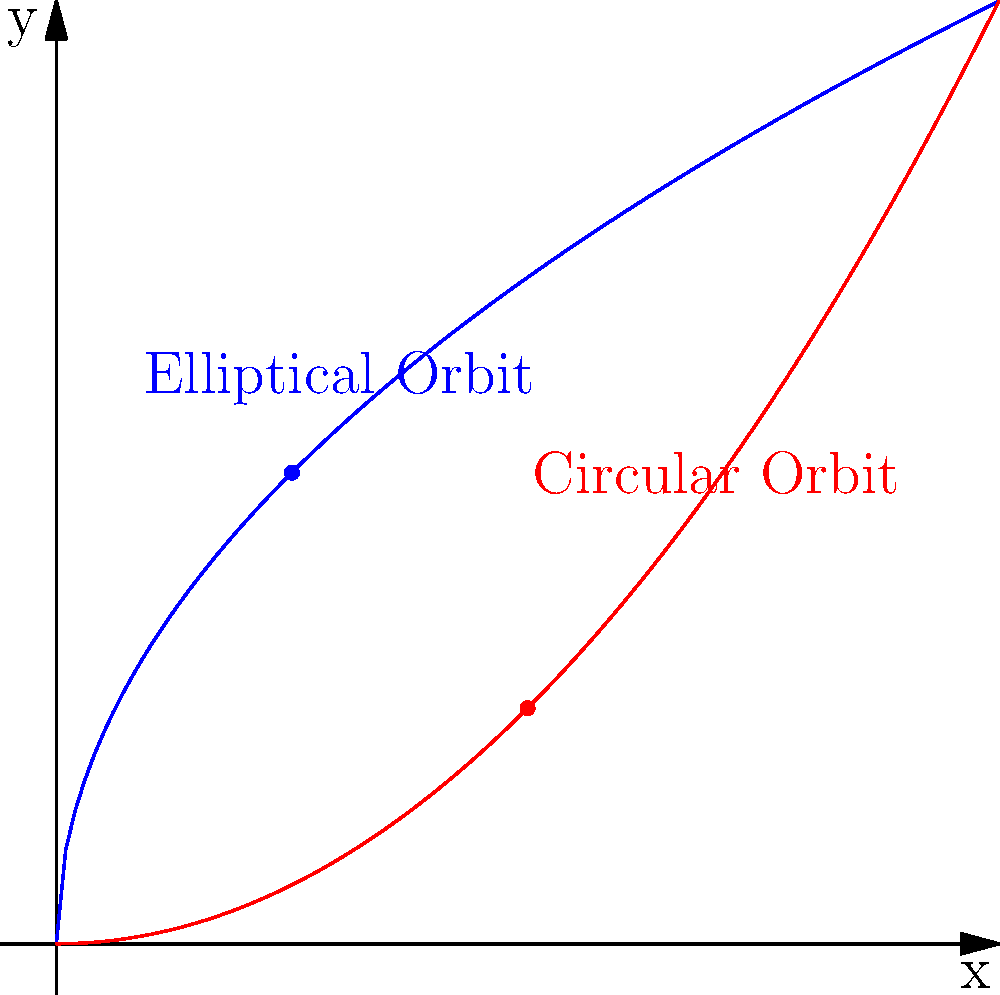Consider the graph above, where the blue curve represents an elliptical orbit and the red curve represents a circular orbit. How does this comparison of planetary orbits reflect the dialectical materialist view of scientific progress, particularly in the context of the transition from Ptolemaic to Copernican models of the solar system? 1. Historical context: The Ptolemaic model (geocentric) assumed perfect circular orbits, while the Copernican model (heliocentric) introduced elliptical orbits.

2. Dialectical materialism: This philosophical approach emphasizes the importance of material conditions and contradictions in driving historical change.

3. Scientific progress: The shift from circular to elliptical orbits represents a qualitative change in understanding, driven by the quantitative accumulation of observational data.

4. Contradiction and synthesis: The circular orbit (thesis) was contradicted by observational data (antithesis), leading to the elliptical orbit model (synthesis).

5. Material basis: The development of more accurate observational tools (e.g., Tycho Brahe's instruments) provided the material conditions for this scientific revolution.

6. Socioeconomic factors: The shift in astronomical models coincided with broader social and economic changes, reflecting the interconnectedness of scientific and social progress.

7. Critique of idealism: The abandonment of perfect circular orbits challenges the idealist notion of celestial perfection, aligning with materialist philosophy.

8. Ongoing process: This example illustrates how scientific knowledge continues to evolve through the resolution of contradictions, as per dialectical materialist theory.
Answer: The transition from circular to elliptical orbits exemplifies dialectical materialist scientific progress, showing how material conditions and contradictions drive qualitative changes in understanding. 